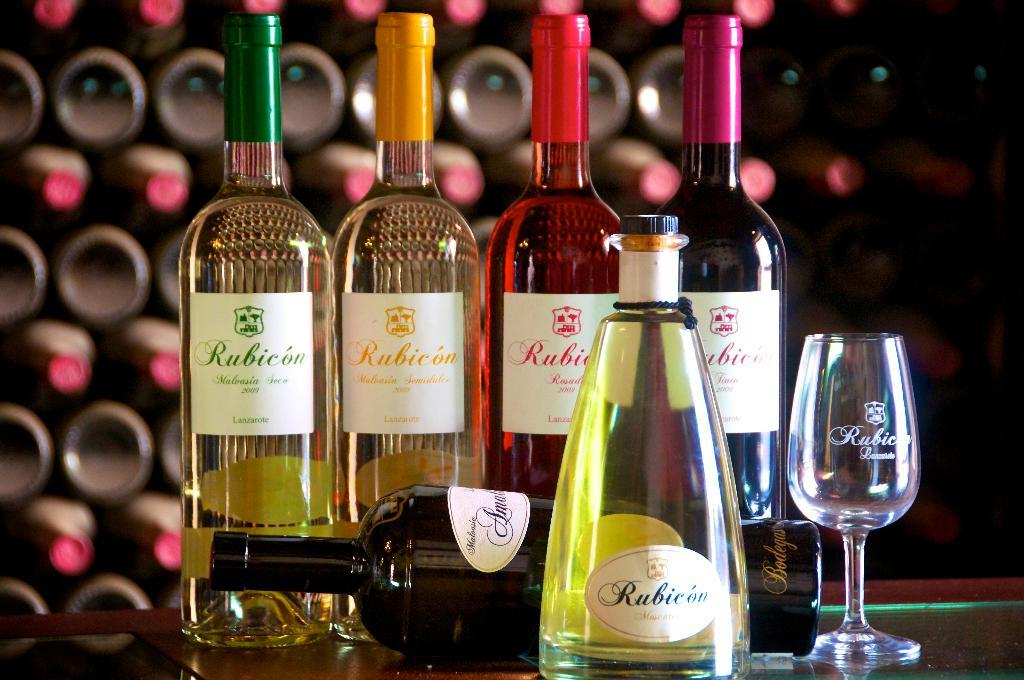<image>
Create a compact narrative representing the image presented. Several bottles of wine with Rubicon on the label. 